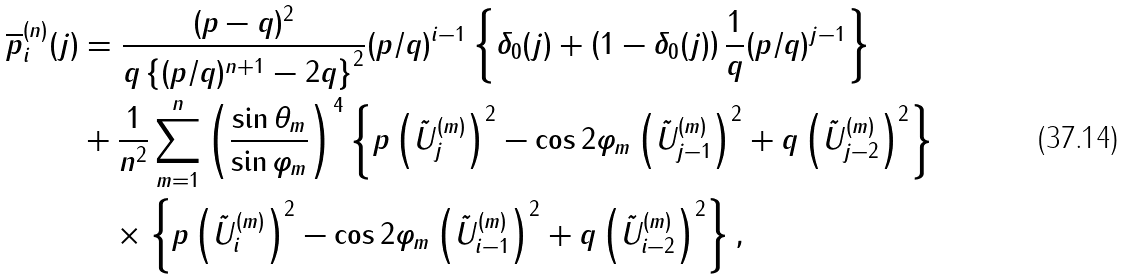Convert formula to latex. <formula><loc_0><loc_0><loc_500><loc_500>\overline { p } _ { i } ^ { ( n ) } ( j ) & = \frac { ( p - q ) ^ { 2 } } { q \left \{ ( p / q ) ^ { n + 1 } - 2 q \right \} ^ { 2 } } ( p / q ) ^ { i - 1 } \left \{ \delta _ { 0 } ( j ) + \left ( 1 - \delta _ { 0 } ( j ) \right ) \frac { 1 } { q } ( p / q ) ^ { j - 1 } \right \} \\ & + \frac { 1 } { n ^ { 2 } } \sum _ { m = 1 } ^ { n } \left ( \frac { \sin \theta _ { m } } { \sin \varphi _ { m } } \right ) ^ { 4 } \left \{ p \left ( \tilde { U } _ { j } ^ { ( m ) } \right ) ^ { 2 } - \cos 2 \varphi _ { m } \left ( \tilde { U } _ { j - 1 } ^ { ( m ) } \right ) ^ { 2 } + q \left ( \tilde { U } _ { j - 2 } ^ { ( m ) } \right ) ^ { 2 } \right \} \\ & \quad \times \left \{ p \left ( \tilde { U } _ { i } ^ { ( m ) } \right ) ^ { 2 } - \cos 2 \varphi _ { m } \left ( \tilde { U } _ { i - 1 } ^ { ( m ) } \right ) ^ { 2 } + q \left ( \tilde { U } _ { i - 2 } ^ { ( m ) } \right ) ^ { 2 } \right \} ,</formula> 